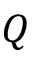<formula> <loc_0><loc_0><loc_500><loc_500>Q</formula> 